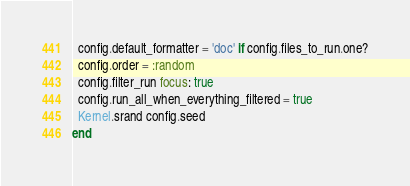Convert code to text. <code><loc_0><loc_0><loc_500><loc_500><_Ruby_>
  config.default_formatter = 'doc' if config.files_to_run.one?
  config.order = :random
  config.filter_run focus: true
  config.run_all_when_everything_filtered = true
  Kernel.srand config.seed
end
</code> 